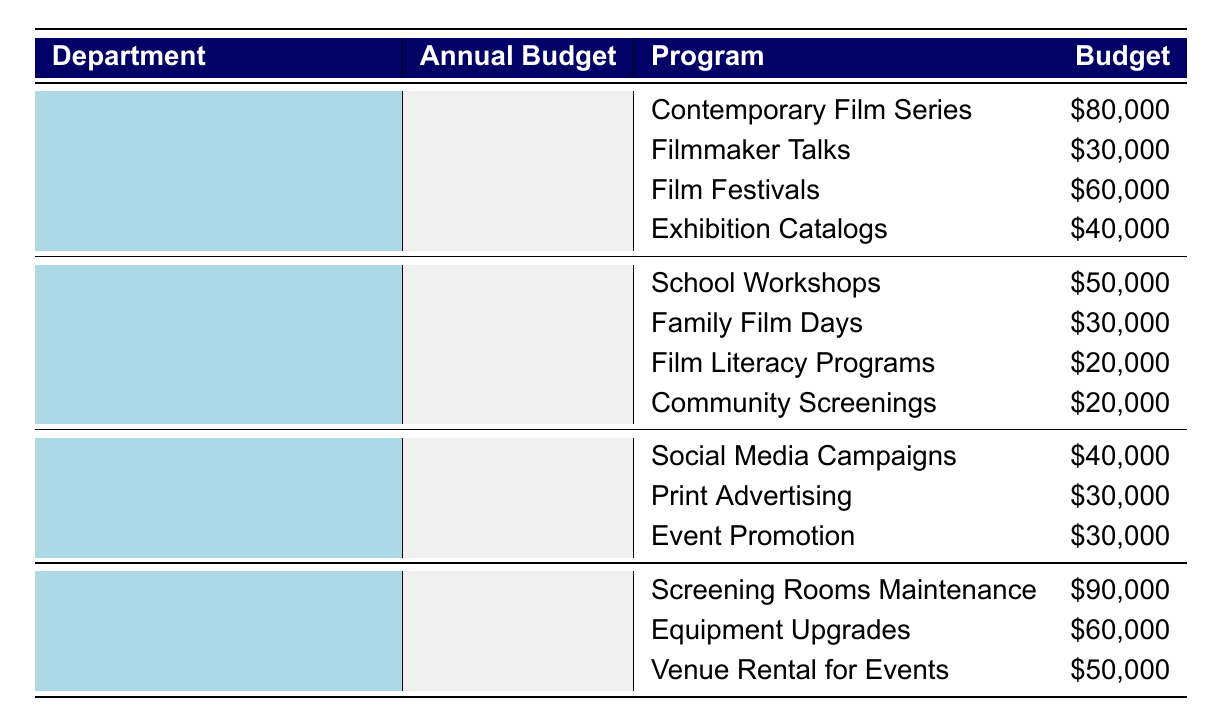What is the total budget for the Film Curation department? The Film Curation department has an annual budget of 250000, which is clearly stated in the table under the Annual Budget column for that department.
Answer: 250000 Which program in Education and Outreach has the highest budget? The programs listed under Education and Outreach are School Workshops, Family Film Days, Film Literacy Programs, and Community Screenings with budgets of 50000, 30000, 20000, and 20000 respectively. The highest budget is for School Workshops at 50000.
Answer: School Workshops What is the combined budget of the Marketing and Promotion programs? The budgets for Marketing and Promotion programs are Social Media Campaigns (40000), Print Advertising (30000), and Event Promotion (30000). Summing these gives us 40000 + 30000 + 30000 = 100000.
Answer: 100000 Is the budget for Film Festivals greater than the budget for Family Film Days? The budget for Film Festivals is 60000, while the budget for Family Film Days is 30000. Since 60000 is greater than 30000, the statement is true.
Answer: Yes What is the average budget allocated per program in the Facilities and Operations department? The Facilities and Operations department has three programs: Screening Rooms Maintenance (90000), Equipment Upgrades (60000), and Venue Rental for Events (50000). The total budget for these programs is 90000 + 60000 + 50000 = 200000. There are three programs, so the average budget is 200000 / 3 = approximately 66667.
Answer: 66667 What is the total budget allocated to the Community Screenings program? Community Screenings is listed under the Education and Outreach department with a budget of 20000, which can be seen directly in the table.
Answer: 20000 Does the Facilities and Operations department have a higher annual budget than the Marketing and Promotion department? Facilities and Operations have an annual budget of 200000, while Marketing and Promotion have an annual budget of 100000. Since 200000 is greater than 100000, the statement is true.
Answer: Yes Which department has the lowest annual budget? The annual budgets for the departments are Film Curation (250000), Education and Outreach (150000), Marketing and Promotion (100000), and Facilities and Operations (200000). The lowest is Marketing and Promotion with 100000.
Answer: Marketing and Promotion 